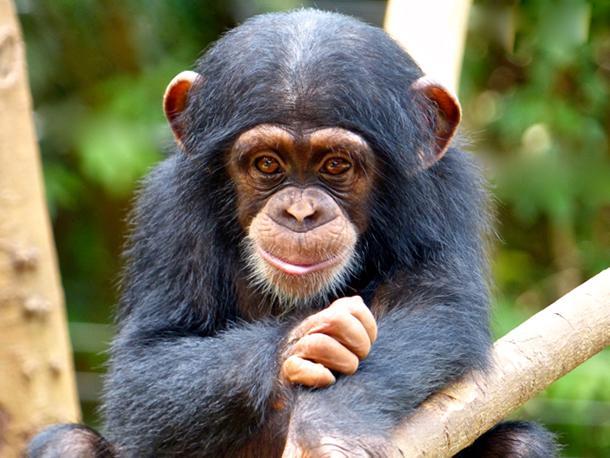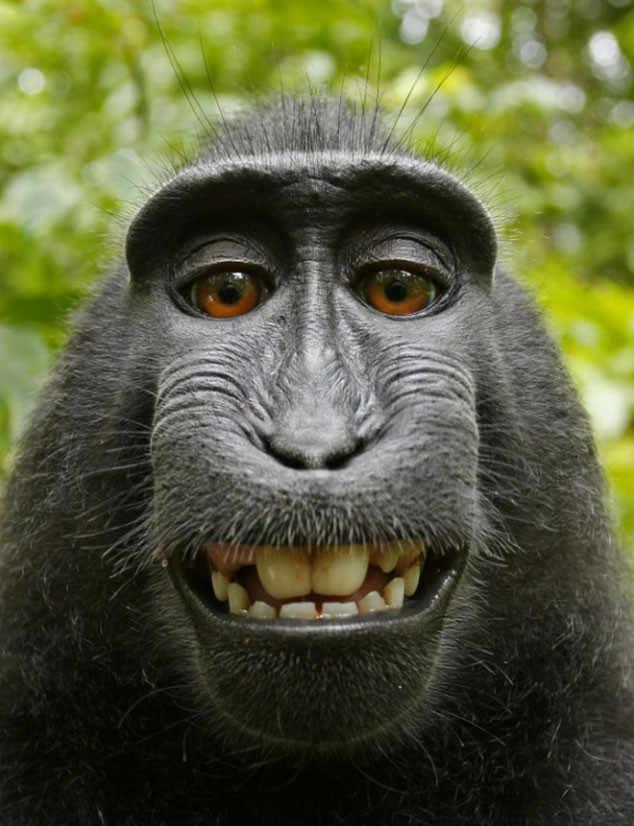The first image is the image on the left, the second image is the image on the right. Analyze the images presented: Is the assertion "The monkey in one of the images is opening its mouth to reveal teeth." valid? Answer yes or no. Yes. The first image is the image on the left, the second image is the image on the right. For the images shown, is this caption "Each image shows one forward-facing young chimp with a light-colored face and ears that protrude." true? Answer yes or no. No. 